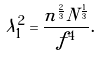<formula> <loc_0><loc_0><loc_500><loc_500>\lambda _ { 1 } ^ { 2 } = \frac { n ^ { \frac { 2 } { 3 } } N ^ { \frac { 1 } { 3 } } } { f ^ { 4 } } .</formula> 